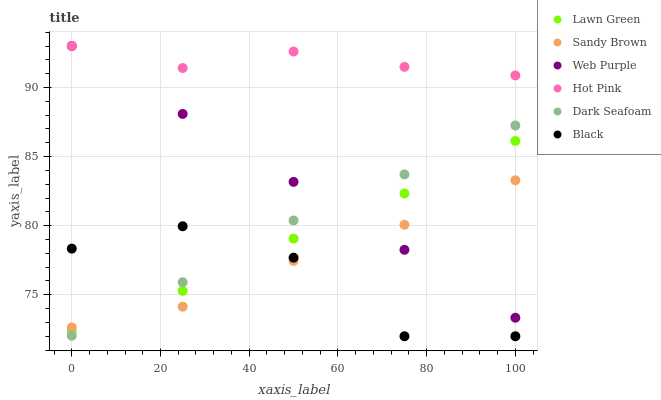Does Black have the minimum area under the curve?
Answer yes or no. Yes. Does Hot Pink have the maximum area under the curve?
Answer yes or no. Yes. Does Dark Seafoam have the minimum area under the curve?
Answer yes or no. No. Does Dark Seafoam have the maximum area under the curve?
Answer yes or no. No. Is Web Purple the smoothest?
Answer yes or no. Yes. Is Black the roughest?
Answer yes or no. Yes. Is Hot Pink the smoothest?
Answer yes or no. No. Is Hot Pink the roughest?
Answer yes or no. No. Does Black have the lowest value?
Answer yes or no. Yes. Does Dark Seafoam have the lowest value?
Answer yes or no. No. Does Web Purple have the highest value?
Answer yes or no. Yes. Does Dark Seafoam have the highest value?
Answer yes or no. No. Is Black less than Web Purple?
Answer yes or no. Yes. Is Hot Pink greater than Sandy Brown?
Answer yes or no. Yes. Does Sandy Brown intersect Web Purple?
Answer yes or no. Yes. Is Sandy Brown less than Web Purple?
Answer yes or no. No. Is Sandy Brown greater than Web Purple?
Answer yes or no. No. Does Black intersect Web Purple?
Answer yes or no. No. 